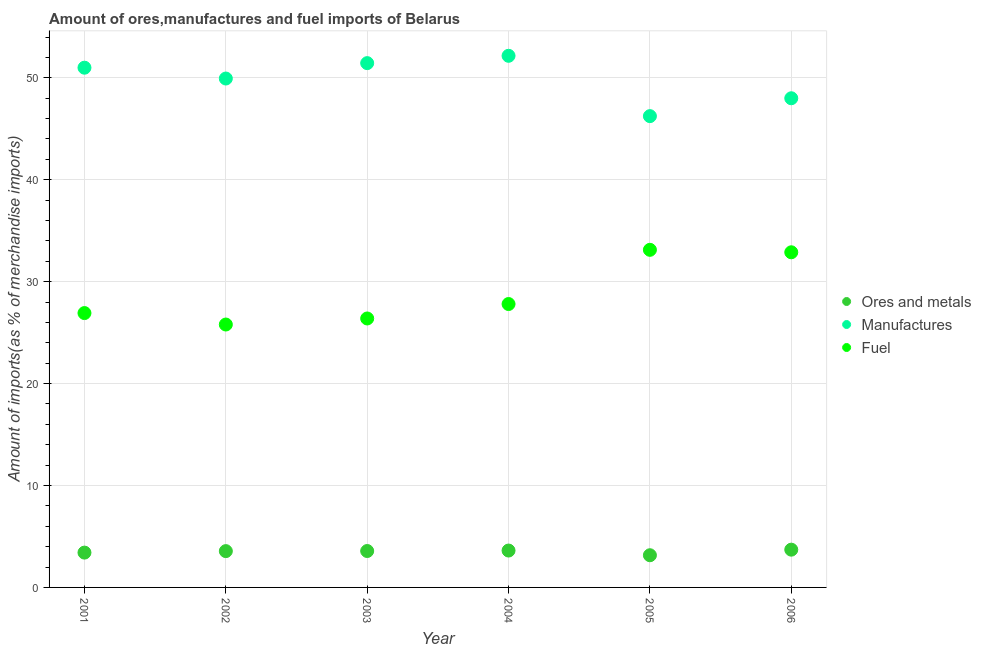How many different coloured dotlines are there?
Offer a very short reply. 3. Is the number of dotlines equal to the number of legend labels?
Ensure brevity in your answer.  Yes. What is the percentage of fuel imports in 2006?
Make the answer very short. 32.88. Across all years, what is the maximum percentage of manufactures imports?
Your response must be concise. 52.16. Across all years, what is the minimum percentage of ores and metals imports?
Your answer should be very brief. 3.16. In which year was the percentage of ores and metals imports maximum?
Keep it short and to the point. 2006. In which year was the percentage of ores and metals imports minimum?
Give a very brief answer. 2005. What is the total percentage of ores and metals imports in the graph?
Provide a succinct answer. 21.03. What is the difference between the percentage of manufactures imports in 2002 and that in 2005?
Keep it short and to the point. 3.69. What is the difference between the percentage of manufactures imports in 2003 and the percentage of ores and metals imports in 2002?
Provide a succinct answer. 47.88. What is the average percentage of manufactures imports per year?
Provide a succinct answer. 49.79. In the year 2002, what is the difference between the percentage of ores and metals imports and percentage of manufactures imports?
Your answer should be compact. -46.37. What is the ratio of the percentage of ores and metals imports in 2003 to that in 2006?
Keep it short and to the point. 0.96. Is the difference between the percentage of manufactures imports in 2002 and 2005 greater than the difference between the percentage of fuel imports in 2002 and 2005?
Offer a terse response. Yes. What is the difference between the highest and the second highest percentage of ores and metals imports?
Your answer should be compact. 0.09. What is the difference between the highest and the lowest percentage of ores and metals imports?
Your answer should be compact. 0.55. Is the sum of the percentage of ores and metals imports in 2004 and 2006 greater than the maximum percentage of fuel imports across all years?
Give a very brief answer. No. Is it the case that in every year, the sum of the percentage of ores and metals imports and percentage of manufactures imports is greater than the percentage of fuel imports?
Make the answer very short. Yes. Does the percentage of ores and metals imports monotonically increase over the years?
Your response must be concise. No. Is the percentage of fuel imports strictly greater than the percentage of ores and metals imports over the years?
Make the answer very short. Yes. How many dotlines are there?
Ensure brevity in your answer.  3. How many years are there in the graph?
Your answer should be compact. 6. What is the difference between two consecutive major ticks on the Y-axis?
Give a very brief answer. 10. Are the values on the major ticks of Y-axis written in scientific E-notation?
Offer a terse response. No. How many legend labels are there?
Your response must be concise. 3. How are the legend labels stacked?
Give a very brief answer. Vertical. What is the title of the graph?
Provide a short and direct response. Amount of ores,manufactures and fuel imports of Belarus. Does "Consumption Tax" appear as one of the legend labels in the graph?
Provide a short and direct response. No. What is the label or title of the X-axis?
Ensure brevity in your answer.  Year. What is the label or title of the Y-axis?
Offer a terse response. Amount of imports(as % of merchandise imports). What is the Amount of imports(as % of merchandise imports) of Ores and metals in 2001?
Ensure brevity in your answer.  3.42. What is the Amount of imports(as % of merchandise imports) in Manufactures in 2001?
Make the answer very short. 50.99. What is the Amount of imports(as % of merchandise imports) of Fuel in 2001?
Your response must be concise. 26.92. What is the Amount of imports(as % of merchandise imports) of Ores and metals in 2002?
Your answer should be very brief. 3.56. What is the Amount of imports(as % of merchandise imports) of Manufactures in 2002?
Keep it short and to the point. 49.93. What is the Amount of imports(as % of merchandise imports) in Fuel in 2002?
Offer a terse response. 25.79. What is the Amount of imports(as % of merchandise imports) of Ores and metals in 2003?
Your answer should be compact. 3.57. What is the Amount of imports(as % of merchandise imports) of Manufactures in 2003?
Make the answer very short. 51.44. What is the Amount of imports(as % of merchandise imports) in Fuel in 2003?
Give a very brief answer. 26.39. What is the Amount of imports(as % of merchandise imports) in Ores and metals in 2004?
Your response must be concise. 3.62. What is the Amount of imports(as % of merchandise imports) in Manufactures in 2004?
Keep it short and to the point. 52.16. What is the Amount of imports(as % of merchandise imports) of Fuel in 2004?
Give a very brief answer. 27.81. What is the Amount of imports(as % of merchandise imports) in Ores and metals in 2005?
Offer a terse response. 3.16. What is the Amount of imports(as % of merchandise imports) in Manufactures in 2005?
Offer a very short reply. 46.24. What is the Amount of imports(as % of merchandise imports) of Fuel in 2005?
Make the answer very short. 33.12. What is the Amount of imports(as % of merchandise imports) in Ores and metals in 2006?
Ensure brevity in your answer.  3.71. What is the Amount of imports(as % of merchandise imports) of Manufactures in 2006?
Provide a short and direct response. 47.99. What is the Amount of imports(as % of merchandise imports) in Fuel in 2006?
Offer a very short reply. 32.88. Across all years, what is the maximum Amount of imports(as % of merchandise imports) in Ores and metals?
Your answer should be compact. 3.71. Across all years, what is the maximum Amount of imports(as % of merchandise imports) of Manufactures?
Offer a terse response. 52.16. Across all years, what is the maximum Amount of imports(as % of merchandise imports) in Fuel?
Provide a short and direct response. 33.12. Across all years, what is the minimum Amount of imports(as % of merchandise imports) of Ores and metals?
Offer a terse response. 3.16. Across all years, what is the minimum Amount of imports(as % of merchandise imports) of Manufactures?
Provide a short and direct response. 46.24. Across all years, what is the minimum Amount of imports(as % of merchandise imports) in Fuel?
Ensure brevity in your answer.  25.79. What is the total Amount of imports(as % of merchandise imports) in Ores and metals in the graph?
Provide a short and direct response. 21.03. What is the total Amount of imports(as % of merchandise imports) in Manufactures in the graph?
Ensure brevity in your answer.  298.76. What is the total Amount of imports(as % of merchandise imports) of Fuel in the graph?
Give a very brief answer. 172.91. What is the difference between the Amount of imports(as % of merchandise imports) in Ores and metals in 2001 and that in 2002?
Keep it short and to the point. -0.15. What is the difference between the Amount of imports(as % of merchandise imports) in Manufactures in 2001 and that in 2002?
Offer a very short reply. 1.06. What is the difference between the Amount of imports(as % of merchandise imports) in Fuel in 2001 and that in 2002?
Make the answer very short. 1.12. What is the difference between the Amount of imports(as % of merchandise imports) in Ores and metals in 2001 and that in 2003?
Provide a succinct answer. -0.16. What is the difference between the Amount of imports(as % of merchandise imports) in Manufactures in 2001 and that in 2003?
Ensure brevity in your answer.  -0.45. What is the difference between the Amount of imports(as % of merchandise imports) in Fuel in 2001 and that in 2003?
Provide a succinct answer. 0.53. What is the difference between the Amount of imports(as % of merchandise imports) in Ores and metals in 2001 and that in 2004?
Keep it short and to the point. -0.2. What is the difference between the Amount of imports(as % of merchandise imports) of Manufactures in 2001 and that in 2004?
Offer a very short reply. -1.17. What is the difference between the Amount of imports(as % of merchandise imports) of Fuel in 2001 and that in 2004?
Offer a very short reply. -0.89. What is the difference between the Amount of imports(as % of merchandise imports) of Ores and metals in 2001 and that in 2005?
Ensure brevity in your answer.  0.26. What is the difference between the Amount of imports(as % of merchandise imports) in Manufactures in 2001 and that in 2005?
Your answer should be very brief. 4.75. What is the difference between the Amount of imports(as % of merchandise imports) in Fuel in 2001 and that in 2005?
Provide a succinct answer. -6.21. What is the difference between the Amount of imports(as % of merchandise imports) of Ores and metals in 2001 and that in 2006?
Give a very brief answer. -0.29. What is the difference between the Amount of imports(as % of merchandise imports) in Manufactures in 2001 and that in 2006?
Give a very brief answer. 3. What is the difference between the Amount of imports(as % of merchandise imports) of Fuel in 2001 and that in 2006?
Offer a very short reply. -5.96. What is the difference between the Amount of imports(as % of merchandise imports) of Ores and metals in 2002 and that in 2003?
Your answer should be compact. -0.01. What is the difference between the Amount of imports(as % of merchandise imports) in Manufactures in 2002 and that in 2003?
Ensure brevity in your answer.  -1.51. What is the difference between the Amount of imports(as % of merchandise imports) of Fuel in 2002 and that in 2003?
Offer a terse response. -0.59. What is the difference between the Amount of imports(as % of merchandise imports) of Ores and metals in 2002 and that in 2004?
Your answer should be compact. -0.06. What is the difference between the Amount of imports(as % of merchandise imports) of Manufactures in 2002 and that in 2004?
Provide a succinct answer. -2.23. What is the difference between the Amount of imports(as % of merchandise imports) of Fuel in 2002 and that in 2004?
Offer a very short reply. -2.01. What is the difference between the Amount of imports(as % of merchandise imports) of Ores and metals in 2002 and that in 2005?
Provide a succinct answer. 0.4. What is the difference between the Amount of imports(as % of merchandise imports) of Manufactures in 2002 and that in 2005?
Provide a succinct answer. 3.69. What is the difference between the Amount of imports(as % of merchandise imports) in Fuel in 2002 and that in 2005?
Your answer should be very brief. -7.33. What is the difference between the Amount of imports(as % of merchandise imports) in Ores and metals in 2002 and that in 2006?
Offer a very short reply. -0.14. What is the difference between the Amount of imports(as % of merchandise imports) in Manufactures in 2002 and that in 2006?
Provide a succinct answer. 1.94. What is the difference between the Amount of imports(as % of merchandise imports) of Fuel in 2002 and that in 2006?
Keep it short and to the point. -7.09. What is the difference between the Amount of imports(as % of merchandise imports) in Ores and metals in 2003 and that in 2004?
Ensure brevity in your answer.  -0.05. What is the difference between the Amount of imports(as % of merchandise imports) of Manufactures in 2003 and that in 2004?
Your answer should be compact. -0.72. What is the difference between the Amount of imports(as % of merchandise imports) of Fuel in 2003 and that in 2004?
Keep it short and to the point. -1.42. What is the difference between the Amount of imports(as % of merchandise imports) in Ores and metals in 2003 and that in 2005?
Make the answer very short. 0.41. What is the difference between the Amount of imports(as % of merchandise imports) in Manufactures in 2003 and that in 2005?
Ensure brevity in your answer.  5.2. What is the difference between the Amount of imports(as % of merchandise imports) of Fuel in 2003 and that in 2005?
Your answer should be very brief. -6.74. What is the difference between the Amount of imports(as % of merchandise imports) of Ores and metals in 2003 and that in 2006?
Give a very brief answer. -0.13. What is the difference between the Amount of imports(as % of merchandise imports) in Manufactures in 2003 and that in 2006?
Offer a terse response. 3.45. What is the difference between the Amount of imports(as % of merchandise imports) in Fuel in 2003 and that in 2006?
Keep it short and to the point. -6.49. What is the difference between the Amount of imports(as % of merchandise imports) of Ores and metals in 2004 and that in 2005?
Your answer should be very brief. 0.46. What is the difference between the Amount of imports(as % of merchandise imports) in Manufactures in 2004 and that in 2005?
Provide a succinct answer. 5.92. What is the difference between the Amount of imports(as % of merchandise imports) of Fuel in 2004 and that in 2005?
Ensure brevity in your answer.  -5.32. What is the difference between the Amount of imports(as % of merchandise imports) of Ores and metals in 2004 and that in 2006?
Give a very brief answer. -0.09. What is the difference between the Amount of imports(as % of merchandise imports) of Manufactures in 2004 and that in 2006?
Keep it short and to the point. 4.17. What is the difference between the Amount of imports(as % of merchandise imports) in Fuel in 2004 and that in 2006?
Keep it short and to the point. -5.08. What is the difference between the Amount of imports(as % of merchandise imports) in Ores and metals in 2005 and that in 2006?
Keep it short and to the point. -0.55. What is the difference between the Amount of imports(as % of merchandise imports) of Manufactures in 2005 and that in 2006?
Your answer should be very brief. -1.75. What is the difference between the Amount of imports(as % of merchandise imports) in Fuel in 2005 and that in 2006?
Provide a succinct answer. 0.24. What is the difference between the Amount of imports(as % of merchandise imports) of Ores and metals in 2001 and the Amount of imports(as % of merchandise imports) of Manufactures in 2002?
Provide a succinct answer. -46.51. What is the difference between the Amount of imports(as % of merchandise imports) of Ores and metals in 2001 and the Amount of imports(as % of merchandise imports) of Fuel in 2002?
Offer a very short reply. -22.38. What is the difference between the Amount of imports(as % of merchandise imports) of Manufactures in 2001 and the Amount of imports(as % of merchandise imports) of Fuel in 2002?
Offer a very short reply. 25.2. What is the difference between the Amount of imports(as % of merchandise imports) of Ores and metals in 2001 and the Amount of imports(as % of merchandise imports) of Manufactures in 2003?
Give a very brief answer. -48.02. What is the difference between the Amount of imports(as % of merchandise imports) in Ores and metals in 2001 and the Amount of imports(as % of merchandise imports) in Fuel in 2003?
Your answer should be very brief. -22.97. What is the difference between the Amount of imports(as % of merchandise imports) of Manufactures in 2001 and the Amount of imports(as % of merchandise imports) of Fuel in 2003?
Offer a very short reply. 24.6. What is the difference between the Amount of imports(as % of merchandise imports) of Ores and metals in 2001 and the Amount of imports(as % of merchandise imports) of Manufactures in 2004?
Provide a succinct answer. -48.74. What is the difference between the Amount of imports(as % of merchandise imports) of Ores and metals in 2001 and the Amount of imports(as % of merchandise imports) of Fuel in 2004?
Ensure brevity in your answer.  -24.39. What is the difference between the Amount of imports(as % of merchandise imports) of Manufactures in 2001 and the Amount of imports(as % of merchandise imports) of Fuel in 2004?
Give a very brief answer. 23.19. What is the difference between the Amount of imports(as % of merchandise imports) of Ores and metals in 2001 and the Amount of imports(as % of merchandise imports) of Manufactures in 2005?
Provide a short and direct response. -42.82. What is the difference between the Amount of imports(as % of merchandise imports) in Ores and metals in 2001 and the Amount of imports(as % of merchandise imports) in Fuel in 2005?
Offer a very short reply. -29.71. What is the difference between the Amount of imports(as % of merchandise imports) in Manufactures in 2001 and the Amount of imports(as % of merchandise imports) in Fuel in 2005?
Offer a terse response. 17.87. What is the difference between the Amount of imports(as % of merchandise imports) of Ores and metals in 2001 and the Amount of imports(as % of merchandise imports) of Manufactures in 2006?
Make the answer very short. -44.58. What is the difference between the Amount of imports(as % of merchandise imports) in Ores and metals in 2001 and the Amount of imports(as % of merchandise imports) in Fuel in 2006?
Your answer should be very brief. -29.47. What is the difference between the Amount of imports(as % of merchandise imports) of Manufactures in 2001 and the Amount of imports(as % of merchandise imports) of Fuel in 2006?
Make the answer very short. 18.11. What is the difference between the Amount of imports(as % of merchandise imports) in Ores and metals in 2002 and the Amount of imports(as % of merchandise imports) in Manufactures in 2003?
Offer a very short reply. -47.88. What is the difference between the Amount of imports(as % of merchandise imports) of Ores and metals in 2002 and the Amount of imports(as % of merchandise imports) of Fuel in 2003?
Provide a short and direct response. -22.83. What is the difference between the Amount of imports(as % of merchandise imports) in Manufactures in 2002 and the Amount of imports(as % of merchandise imports) in Fuel in 2003?
Offer a terse response. 23.54. What is the difference between the Amount of imports(as % of merchandise imports) in Ores and metals in 2002 and the Amount of imports(as % of merchandise imports) in Manufactures in 2004?
Offer a very short reply. -48.6. What is the difference between the Amount of imports(as % of merchandise imports) in Ores and metals in 2002 and the Amount of imports(as % of merchandise imports) in Fuel in 2004?
Give a very brief answer. -24.24. What is the difference between the Amount of imports(as % of merchandise imports) of Manufactures in 2002 and the Amount of imports(as % of merchandise imports) of Fuel in 2004?
Offer a very short reply. 22.12. What is the difference between the Amount of imports(as % of merchandise imports) of Ores and metals in 2002 and the Amount of imports(as % of merchandise imports) of Manufactures in 2005?
Ensure brevity in your answer.  -42.68. What is the difference between the Amount of imports(as % of merchandise imports) of Ores and metals in 2002 and the Amount of imports(as % of merchandise imports) of Fuel in 2005?
Ensure brevity in your answer.  -29.56. What is the difference between the Amount of imports(as % of merchandise imports) in Manufactures in 2002 and the Amount of imports(as % of merchandise imports) in Fuel in 2005?
Offer a terse response. 16.81. What is the difference between the Amount of imports(as % of merchandise imports) in Ores and metals in 2002 and the Amount of imports(as % of merchandise imports) in Manufactures in 2006?
Ensure brevity in your answer.  -44.43. What is the difference between the Amount of imports(as % of merchandise imports) in Ores and metals in 2002 and the Amount of imports(as % of merchandise imports) in Fuel in 2006?
Give a very brief answer. -29.32. What is the difference between the Amount of imports(as % of merchandise imports) of Manufactures in 2002 and the Amount of imports(as % of merchandise imports) of Fuel in 2006?
Keep it short and to the point. 17.05. What is the difference between the Amount of imports(as % of merchandise imports) in Ores and metals in 2003 and the Amount of imports(as % of merchandise imports) in Manufactures in 2004?
Offer a terse response. -48.59. What is the difference between the Amount of imports(as % of merchandise imports) of Ores and metals in 2003 and the Amount of imports(as % of merchandise imports) of Fuel in 2004?
Your response must be concise. -24.23. What is the difference between the Amount of imports(as % of merchandise imports) of Manufactures in 2003 and the Amount of imports(as % of merchandise imports) of Fuel in 2004?
Keep it short and to the point. 23.64. What is the difference between the Amount of imports(as % of merchandise imports) of Ores and metals in 2003 and the Amount of imports(as % of merchandise imports) of Manufactures in 2005?
Offer a terse response. -42.67. What is the difference between the Amount of imports(as % of merchandise imports) in Ores and metals in 2003 and the Amount of imports(as % of merchandise imports) in Fuel in 2005?
Offer a very short reply. -29.55. What is the difference between the Amount of imports(as % of merchandise imports) of Manufactures in 2003 and the Amount of imports(as % of merchandise imports) of Fuel in 2005?
Provide a succinct answer. 18.32. What is the difference between the Amount of imports(as % of merchandise imports) of Ores and metals in 2003 and the Amount of imports(as % of merchandise imports) of Manufactures in 2006?
Offer a very short reply. -44.42. What is the difference between the Amount of imports(as % of merchandise imports) in Ores and metals in 2003 and the Amount of imports(as % of merchandise imports) in Fuel in 2006?
Offer a very short reply. -29.31. What is the difference between the Amount of imports(as % of merchandise imports) in Manufactures in 2003 and the Amount of imports(as % of merchandise imports) in Fuel in 2006?
Offer a terse response. 18.56. What is the difference between the Amount of imports(as % of merchandise imports) in Ores and metals in 2004 and the Amount of imports(as % of merchandise imports) in Manufactures in 2005?
Keep it short and to the point. -42.62. What is the difference between the Amount of imports(as % of merchandise imports) in Ores and metals in 2004 and the Amount of imports(as % of merchandise imports) in Fuel in 2005?
Make the answer very short. -29.51. What is the difference between the Amount of imports(as % of merchandise imports) of Manufactures in 2004 and the Amount of imports(as % of merchandise imports) of Fuel in 2005?
Offer a very short reply. 19.04. What is the difference between the Amount of imports(as % of merchandise imports) of Ores and metals in 2004 and the Amount of imports(as % of merchandise imports) of Manufactures in 2006?
Your response must be concise. -44.38. What is the difference between the Amount of imports(as % of merchandise imports) of Ores and metals in 2004 and the Amount of imports(as % of merchandise imports) of Fuel in 2006?
Make the answer very short. -29.26. What is the difference between the Amount of imports(as % of merchandise imports) of Manufactures in 2004 and the Amount of imports(as % of merchandise imports) of Fuel in 2006?
Offer a terse response. 19.28. What is the difference between the Amount of imports(as % of merchandise imports) of Ores and metals in 2005 and the Amount of imports(as % of merchandise imports) of Manufactures in 2006?
Your answer should be very brief. -44.84. What is the difference between the Amount of imports(as % of merchandise imports) of Ores and metals in 2005 and the Amount of imports(as % of merchandise imports) of Fuel in 2006?
Your response must be concise. -29.72. What is the difference between the Amount of imports(as % of merchandise imports) of Manufactures in 2005 and the Amount of imports(as % of merchandise imports) of Fuel in 2006?
Offer a terse response. 13.36. What is the average Amount of imports(as % of merchandise imports) in Ores and metals per year?
Keep it short and to the point. 3.51. What is the average Amount of imports(as % of merchandise imports) of Manufactures per year?
Give a very brief answer. 49.79. What is the average Amount of imports(as % of merchandise imports) of Fuel per year?
Provide a short and direct response. 28.82. In the year 2001, what is the difference between the Amount of imports(as % of merchandise imports) of Ores and metals and Amount of imports(as % of merchandise imports) of Manufactures?
Your answer should be compact. -47.58. In the year 2001, what is the difference between the Amount of imports(as % of merchandise imports) in Ores and metals and Amount of imports(as % of merchandise imports) in Fuel?
Your answer should be compact. -23.5. In the year 2001, what is the difference between the Amount of imports(as % of merchandise imports) in Manufactures and Amount of imports(as % of merchandise imports) in Fuel?
Provide a succinct answer. 24.07. In the year 2002, what is the difference between the Amount of imports(as % of merchandise imports) in Ores and metals and Amount of imports(as % of merchandise imports) in Manufactures?
Keep it short and to the point. -46.37. In the year 2002, what is the difference between the Amount of imports(as % of merchandise imports) in Ores and metals and Amount of imports(as % of merchandise imports) in Fuel?
Your answer should be very brief. -22.23. In the year 2002, what is the difference between the Amount of imports(as % of merchandise imports) in Manufactures and Amount of imports(as % of merchandise imports) in Fuel?
Make the answer very short. 24.14. In the year 2003, what is the difference between the Amount of imports(as % of merchandise imports) of Ores and metals and Amount of imports(as % of merchandise imports) of Manufactures?
Your answer should be compact. -47.87. In the year 2003, what is the difference between the Amount of imports(as % of merchandise imports) of Ores and metals and Amount of imports(as % of merchandise imports) of Fuel?
Offer a very short reply. -22.82. In the year 2003, what is the difference between the Amount of imports(as % of merchandise imports) of Manufactures and Amount of imports(as % of merchandise imports) of Fuel?
Keep it short and to the point. 25.05. In the year 2004, what is the difference between the Amount of imports(as % of merchandise imports) in Ores and metals and Amount of imports(as % of merchandise imports) in Manufactures?
Provide a short and direct response. -48.54. In the year 2004, what is the difference between the Amount of imports(as % of merchandise imports) in Ores and metals and Amount of imports(as % of merchandise imports) in Fuel?
Make the answer very short. -24.19. In the year 2004, what is the difference between the Amount of imports(as % of merchandise imports) of Manufactures and Amount of imports(as % of merchandise imports) of Fuel?
Your answer should be compact. 24.36. In the year 2005, what is the difference between the Amount of imports(as % of merchandise imports) in Ores and metals and Amount of imports(as % of merchandise imports) in Manufactures?
Provide a short and direct response. -43.08. In the year 2005, what is the difference between the Amount of imports(as % of merchandise imports) of Ores and metals and Amount of imports(as % of merchandise imports) of Fuel?
Provide a short and direct response. -29.97. In the year 2005, what is the difference between the Amount of imports(as % of merchandise imports) of Manufactures and Amount of imports(as % of merchandise imports) of Fuel?
Ensure brevity in your answer.  13.12. In the year 2006, what is the difference between the Amount of imports(as % of merchandise imports) in Ores and metals and Amount of imports(as % of merchandise imports) in Manufactures?
Your response must be concise. -44.29. In the year 2006, what is the difference between the Amount of imports(as % of merchandise imports) of Ores and metals and Amount of imports(as % of merchandise imports) of Fuel?
Your answer should be compact. -29.18. In the year 2006, what is the difference between the Amount of imports(as % of merchandise imports) of Manufactures and Amount of imports(as % of merchandise imports) of Fuel?
Make the answer very short. 15.11. What is the ratio of the Amount of imports(as % of merchandise imports) in Ores and metals in 2001 to that in 2002?
Ensure brevity in your answer.  0.96. What is the ratio of the Amount of imports(as % of merchandise imports) of Manufactures in 2001 to that in 2002?
Your response must be concise. 1.02. What is the ratio of the Amount of imports(as % of merchandise imports) of Fuel in 2001 to that in 2002?
Provide a succinct answer. 1.04. What is the ratio of the Amount of imports(as % of merchandise imports) in Ores and metals in 2001 to that in 2003?
Give a very brief answer. 0.96. What is the ratio of the Amount of imports(as % of merchandise imports) of Manufactures in 2001 to that in 2003?
Offer a terse response. 0.99. What is the ratio of the Amount of imports(as % of merchandise imports) in Fuel in 2001 to that in 2003?
Your answer should be very brief. 1.02. What is the ratio of the Amount of imports(as % of merchandise imports) in Ores and metals in 2001 to that in 2004?
Give a very brief answer. 0.94. What is the ratio of the Amount of imports(as % of merchandise imports) of Manufactures in 2001 to that in 2004?
Keep it short and to the point. 0.98. What is the ratio of the Amount of imports(as % of merchandise imports) in Fuel in 2001 to that in 2004?
Provide a succinct answer. 0.97. What is the ratio of the Amount of imports(as % of merchandise imports) of Ores and metals in 2001 to that in 2005?
Your answer should be compact. 1.08. What is the ratio of the Amount of imports(as % of merchandise imports) in Manufactures in 2001 to that in 2005?
Provide a short and direct response. 1.1. What is the ratio of the Amount of imports(as % of merchandise imports) of Fuel in 2001 to that in 2005?
Your answer should be compact. 0.81. What is the ratio of the Amount of imports(as % of merchandise imports) in Ores and metals in 2001 to that in 2006?
Your answer should be compact. 0.92. What is the ratio of the Amount of imports(as % of merchandise imports) of Fuel in 2001 to that in 2006?
Offer a very short reply. 0.82. What is the ratio of the Amount of imports(as % of merchandise imports) in Manufactures in 2002 to that in 2003?
Provide a short and direct response. 0.97. What is the ratio of the Amount of imports(as % of merchandise imports) of Fuel in 2002 to that in 2003?
Your response must be concise. 0.98. What is the ratio of the Amount of imports(as % of merchandise imports) in Ores and metals in 2002 to that in 2004?
Your answer should be very brief. 0.98. What is the ratio of the Amount of imports(as % of merchandise imports) of Manufactures in 2002 to that in 2004?
Provide a short and direct response. 0.96. What is the ratio of the Amount of imports(as % of merchandise imports) of Fuel in 2002 to that in 2004?
Offer a very short reply. 0.93. What is the ratio of the Amount of imports(as % of merchandise imports) in Ores and metals in 2002 to that in 2005?
Ensure brevity in your answer.  1.13. What is the ratio of the Amount of imports(as % of merchandise imports) in Manufactures in 2002 to that in 2005?
Provide a short and direct response. 1.08. What is the ratio of the Amount of imports(as % of merchandise imports) of Fuel in 2002 to that in 2005?
Provide a short and direct response. 0.78. What is the ratio of the Amount of imports(as % of merchandise imports) of Ores and metals in 2002 to that in 2006?
Give a very brief answer. 0.96. What is the ratio of the Amount of imports(as % of merchandise imports) in Manufactures in 2002 to that in 2006?
Your response must be concise. 1.04. What is the ratio of the Amount of imports(as % of merchandise imports) of Fuel in 2002 to that in 2006?
Offer a terse response. 0.78. What is the ratio of the Amount of imports(as % of merchandise imports) of Ores and metals in 2003 to that in 2004?
Provide a succinct answer. 0.99. What is the ratio of the Amount of imports(as % of merchandise imports) of Manufactures in 2003 to that in 2004?
Offer a terse response. 0.99. What is the ratio of the Amount of imports(as % of merchandise imports) in Fuel in 2003 to that in 2004?
Your response must be concise. 0.95. What is the ratio of the Amount of imports(as % of merchandise imports) in Ores and metals in 2003 to that in 2005?
Keep it short and to the point. 1.13. What is the ratio of the Amount of imports(as % of merchandise imports) in Manufactures in 2003 to that in 2005?
Your answer should be very brief. 1.11. What is the ratio of the Amount of imports(as % of merchandise imports) of Fuel in 2003 to that in 2005?
Offer a very short reply. 0.8. What is the ratio of the Amount of imports(as % of merchandise imports) in Ores and metals in 2003 to that in 2006?
Offer a very short reply. 0.96. What is the ratio of the Amount of imports(as % of merchandise imports) in Manufactures in 2003 to that in 2006?
Provide a succinct answer. 1.07. What is the ratio of the Amount of imports(as % of merchandise imports) in Fuel in 2003 to that in 2006?
Your answer should be compact. 0.8. What is the ratio of the Amount of imports(as % of merchandise imports) in Ores and metals in 2004 to that in 2005?
Offer a very short reply. 1.15. What is the ratio of the Amount of imports(as % of merchandise imports) of Manufactures in 2004 to that in 2005?
Ensure brevity in your answer.  1.13. What is the ratio of the Amount of imports(as % of merchandise imports) in Fuel in 2004 to that in 2005?
Your response must be concise. 0.84. What is the ratio of the Amount of imports(as % of merchandise imports) in Ores and metals in 2004 to that in 2006?
Offer a terse response. 0.98. What is the ratio of the Amount of imports(as % of merchandise imports) in Manufactures in 2004 to that in 2006?
Your answer should be very brief. 1.09. What is the ratio of the Amount of imports(as % of merchandise imports) in Fuel in 2004 to that in 2006?
Your answer should be compact. 0.85. What is the ratio of the Amount of imports(as % of merchandise imports) of Ores and metals in 2005 to that in 2006?
Give a very brief answer. 0.85. What is the ratio of the Amount of imports(as % of merchandise imports) in Manufactures in 2005 to that in 2006?
Offer a terse response. 0.96. What is the ratio of the Amount of imports(as % of merchandise imports) of Fuel in 2005 to that in 2006?
Offer a terse response. 1.01. What is the difference between the highest and the second highest Amount of imports(as % of merchandise imports) of Ores and metals?
Your answer should be compact. 0.09. What is the difference between the highest and the second highest Amount of imports(as % of merchandise imports) of Manufactures?
Your answer should be compact. 0.72. What is the difference between the highest and the second highest Amount of imports(as % of merchandise imports) of Fuel?
Give a very brief answer. 0.24. What is the difference between the highest and the lowest Amount of imports(as % of merchandise imports) in Ores and metals?
Provide a succinct answer. 0.55. What is the difference between the highest and the lowest Amount of imports(as % of merchandise imports) of Manufactures?
Make the answer very short. 5.92. What is the difference between the highest and the lowest Amount of imports(as % of merchandise imports) in Fuel?
Your answer should be very brief. 7.33. 